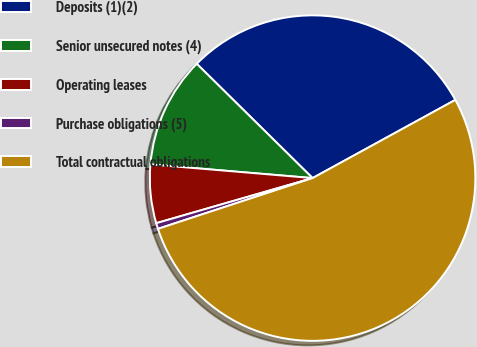<chart> <loc_0><loc_0><loc_500><loc_500><pie_chart><fcel>Deposits (1)(2)<fcel>Senior unsecured notes (4)<fcel>Operating leases<fcel>Purchase obligations (5)<fcel>Total contractual obligations<nl><fcel>29.63%<fcel>11.05%<fcel>5.81%<fcel>0.58%<fcel>52.93%<nl></chart> 